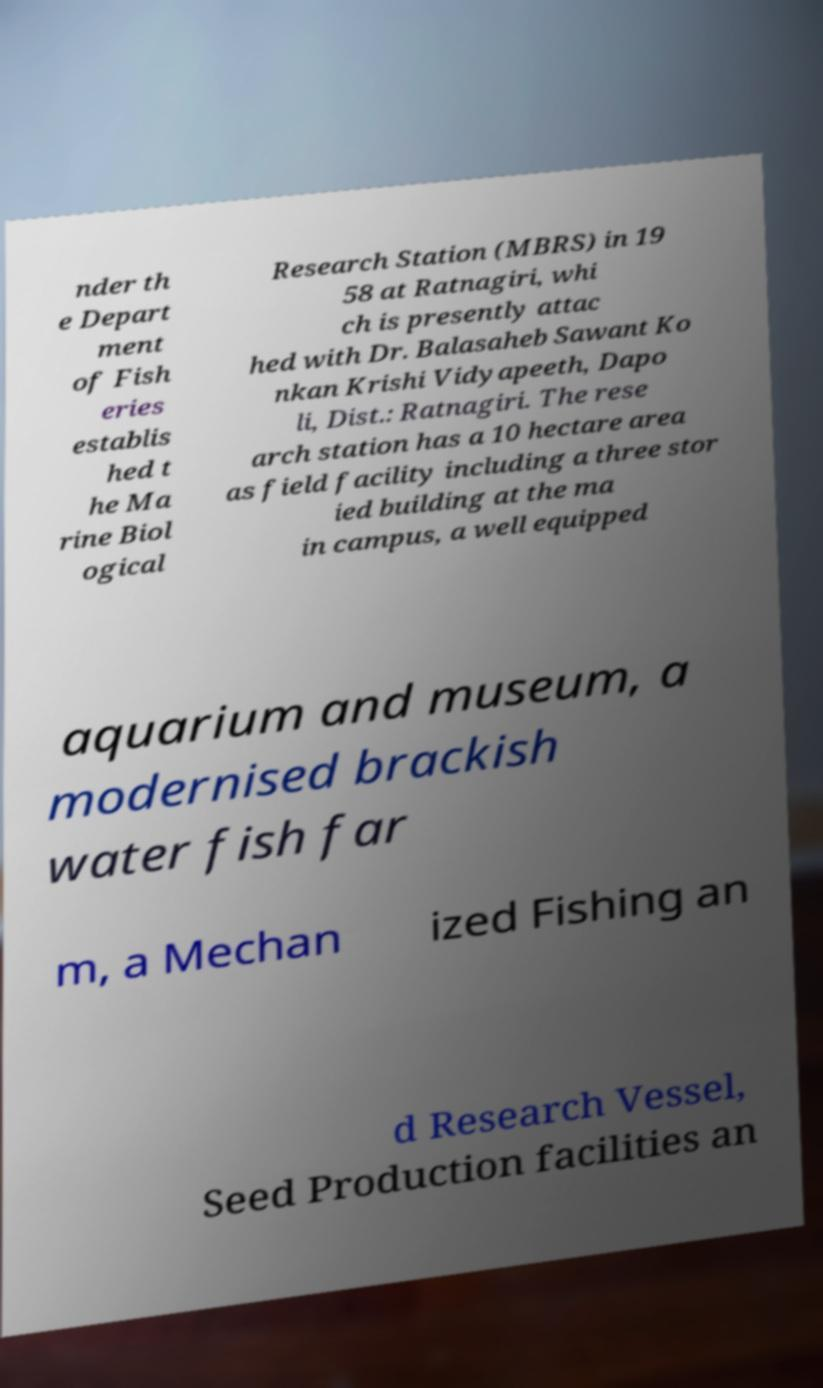There's text embedded in this image that I need extracted. Can you transcribe it verbatim? nder th e Depart ment of Fish eries establis hed t he Ma rine Biol ogical Research Station (MBRS) in 19 58 at Ratnagiri, whi ch is presently attac hed with Dr. Balasaheb Sawant Ko nkan Krishi Vidyapeeth, Dapo li, Dist.: Ratnagiri. The rese arch station has a 10 hectare area as field facility including a three stor ied building at the ma in campus, a well equipped aquarium and museum, a modernised brackish water fish far m, a Mechan ized Fishing an d Research Vessel, Seed Production facilities an 